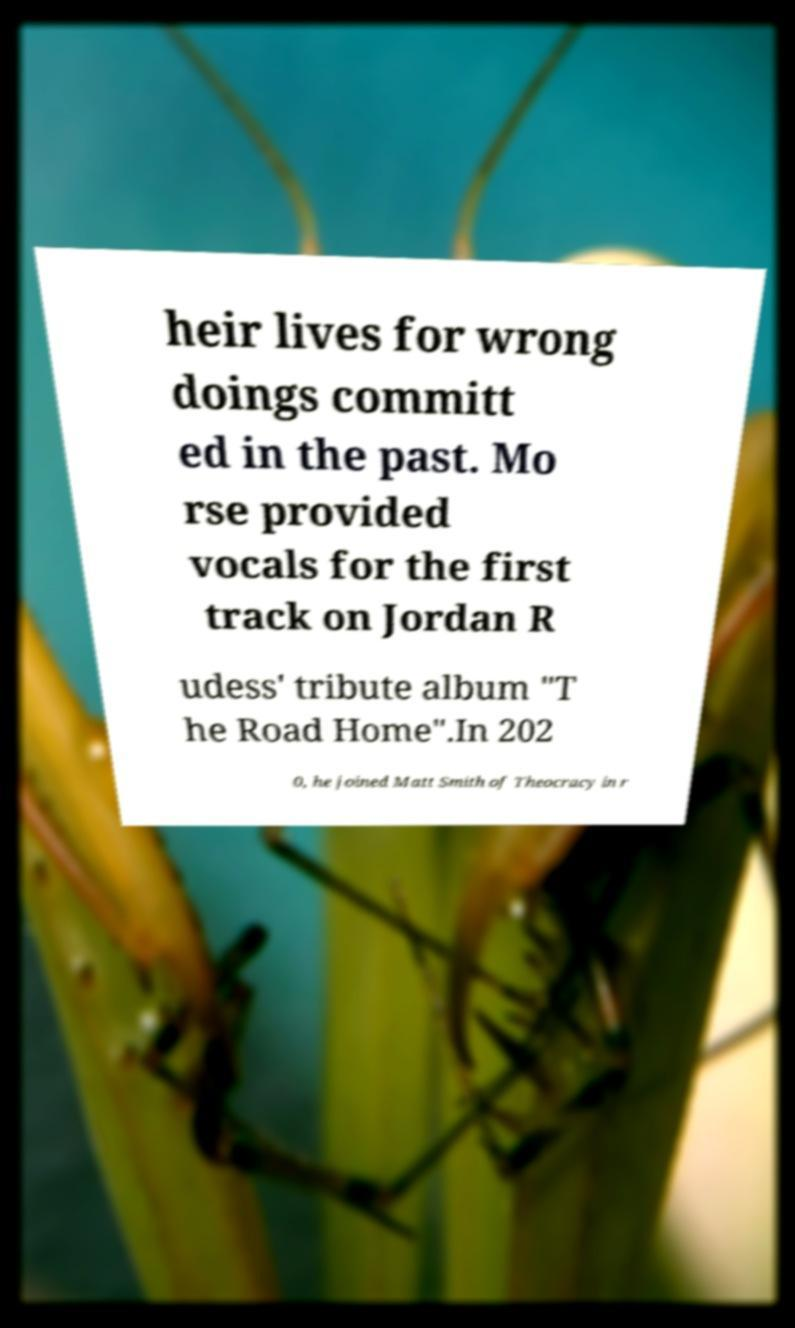Can you read and provide the text displayed in the image?This photo seems to have some interesting text. Can you extract and type it out for me? heir lives for wrong doings committ ed in the past. Mo rse provided vocals for the first track on Jordan R udess' tribute album "T he Road Home".In 202 0, he joined Matt Smith of Theocracy in r 